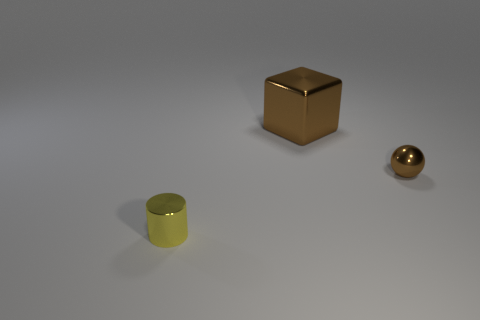Add 2 tiny brown matte blocks. How many objects exist? 5 Subtract 1 spheres. How many spheres are left? 0 Subtract all cylinders. How many objects are left? 2 Subtract all brown cylinders. Subtract all cyan spheres. How many cylinders are left? 1 Subtract all small metal spheres. Subtract all big shiny cubes. How many objects are left? 1 Add 1 small brown shiny balls. How many small brown shiny balls are left? 2 Add 2 tiny cyan metallic objects. How many tiny cyan metallic objects exist? 2 Subtract 0 brown cylinders. How many objects are left? 3 